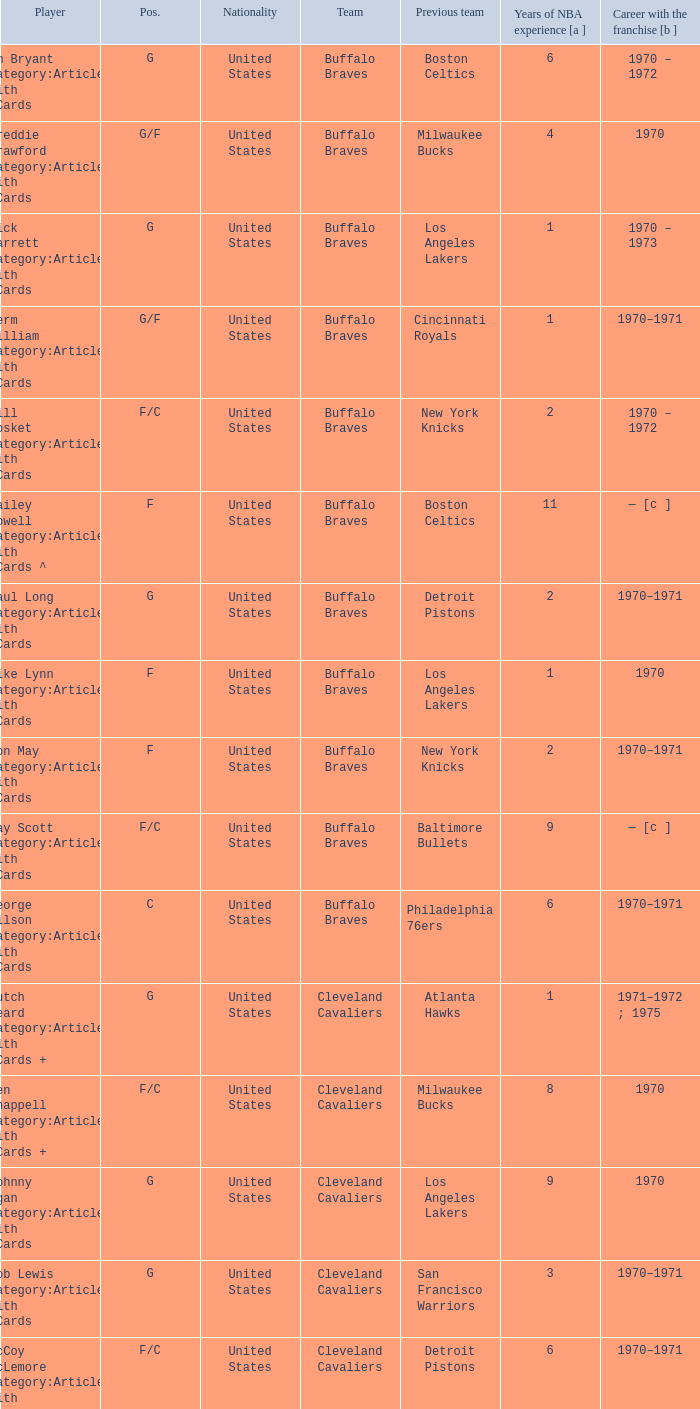Which player has spent 7 years in the nba? Larry Siegfried Category:Articles with hCards. 